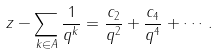Convert formula to latex. <formula><loc_0><loc_0><loc_500><loc_500>z - \sum _ { k \in A } \frac { 1 } { q ^ { k } } = \frac { c _ { 2 } } { q ^ { 2 } } + \frac { c _ { 4 } } { q ^ { 4 } } + \cdots .</formula> 